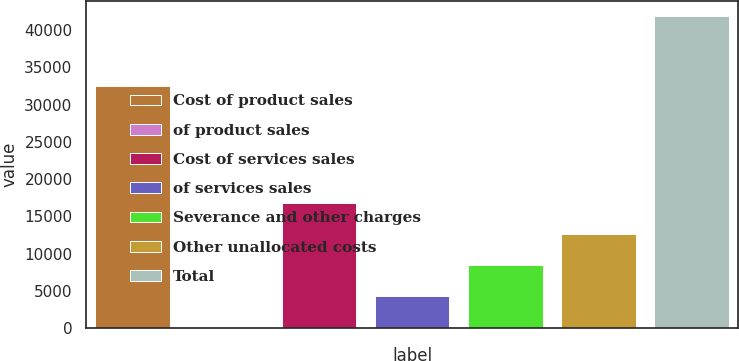Convert chart. <chart><loc_0><loc_0><loc_500><loc_500><bar_chart><fcel>Cost of product sales<fcel>of product sales<fcel>Cost of services sales<fcel>of services sales<fcel>Severance and other charges<fcel>Other unallocated costs<fcel>Total<nl><fcel>32539<fcel>89.4<fcel>16784.4<fcel>4263.16<fcel>8436.92<fcel>12610.7<fcel>41827<nl></chart> 